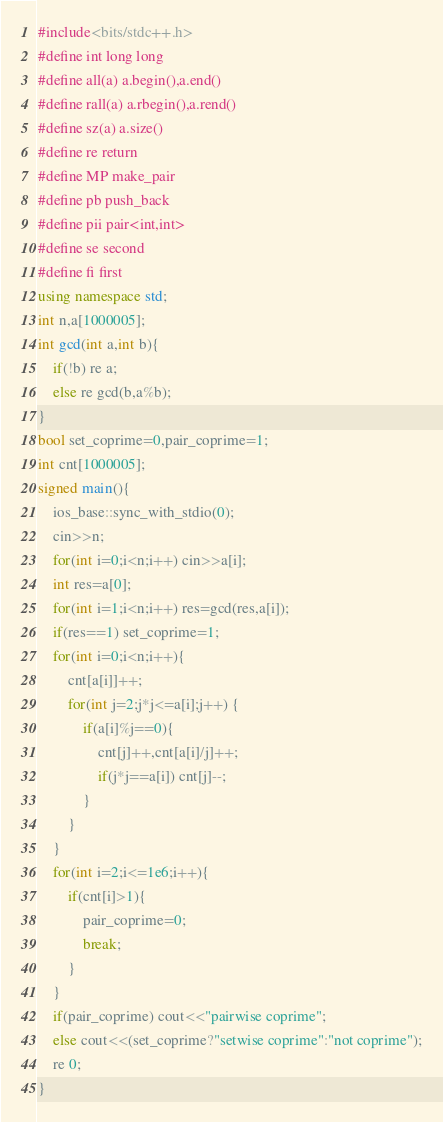<code> <loc_0><loc_0><loc_500><loc_500><_C++_>#include<bits/stdc++.h>
#define int long long
#define all(a) a.begin(),a.end()
#define rall(a) a.rbegin(),a.rend()
#define sz(a) a.size()
#define re return 
#define MP make_pair
#define pb push_back
#define pii pair<int,int>
#define se second
#define fi first
using namespace std;
int n,a[1000005];
int gcd(int a,int b){
	if(!b) re a;
	else re gcd(b,a%b);
}
bool set_coprime=0,pair_coprime=1; 
int cnt[1000005];
signed main(){
	ios_base::sync_with_stdio(0);
	cin>>n;
	for(int i=0;i<n;i++) cin>>a[i];
	int res=a[0];
	for(int i=1;i<n;i++) res=gcd(res,a[i]);
	if(res==1) set_coprime=1;
	for(int i=0;i<n;i++){
		cnt[a[i]]++;
		for(int j=2;j*j<=a[i];j++) {
			if(a[i]%j==0){
				cnt[j]++,cnt[a[i]/j]++;
				if(j*j==a[i]) cnt[j]--;
			}	
		}
	}
	for(int i=2;i<=1e6;i++){
		if(cnt[i]>1){
			pair_coprime=0;
			break;
		}
	}
	if(pair_coprime) cout<<"pairwise coprime";
	else cout<<(set_coprime?"setwise coprime":"not coprime");
	re 0;
}</code> 